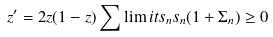<formula> <loc_0><loc_0><loc_500><loc_500>z ^ { \prime } = 2 z ( 1 - z ) \sum \lim i t s _ { n } s _ { n } ( 1 + \Sigma _ { n } ) \geq 0</formula> 